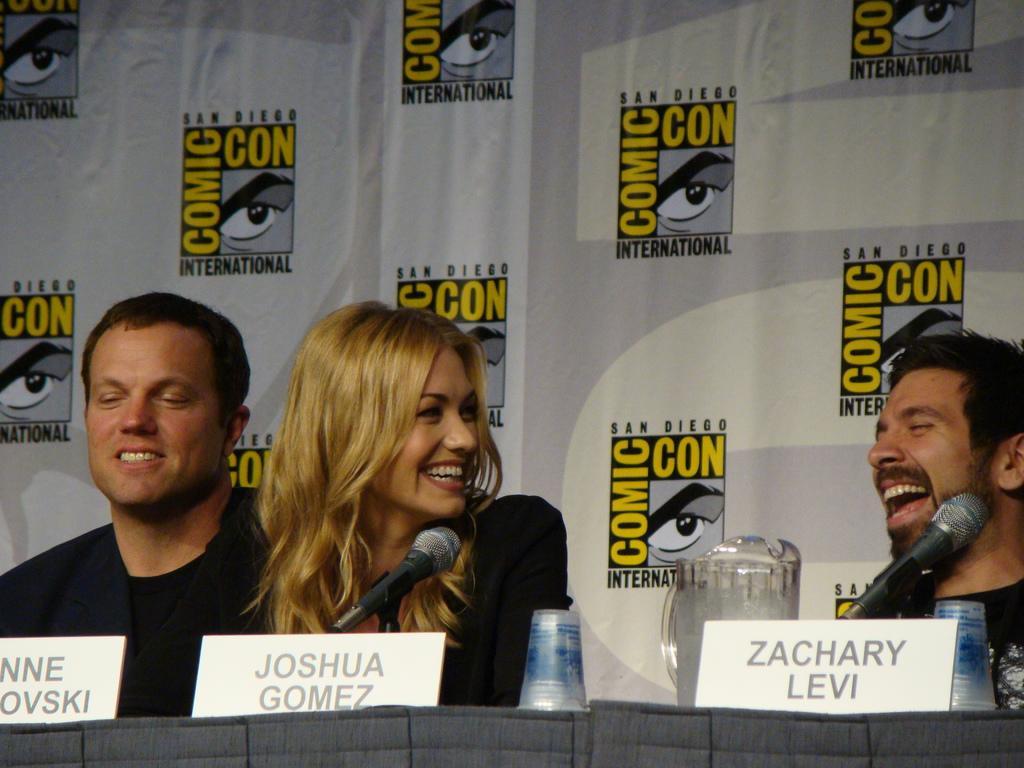Describe this image in one or two sentences. In this image we can see three persons sitting on chairs behind table smiling and there are some microphones, name boards, glasses and jug on table and kin the background of the image there is white color sheet of which there are some paintings. 